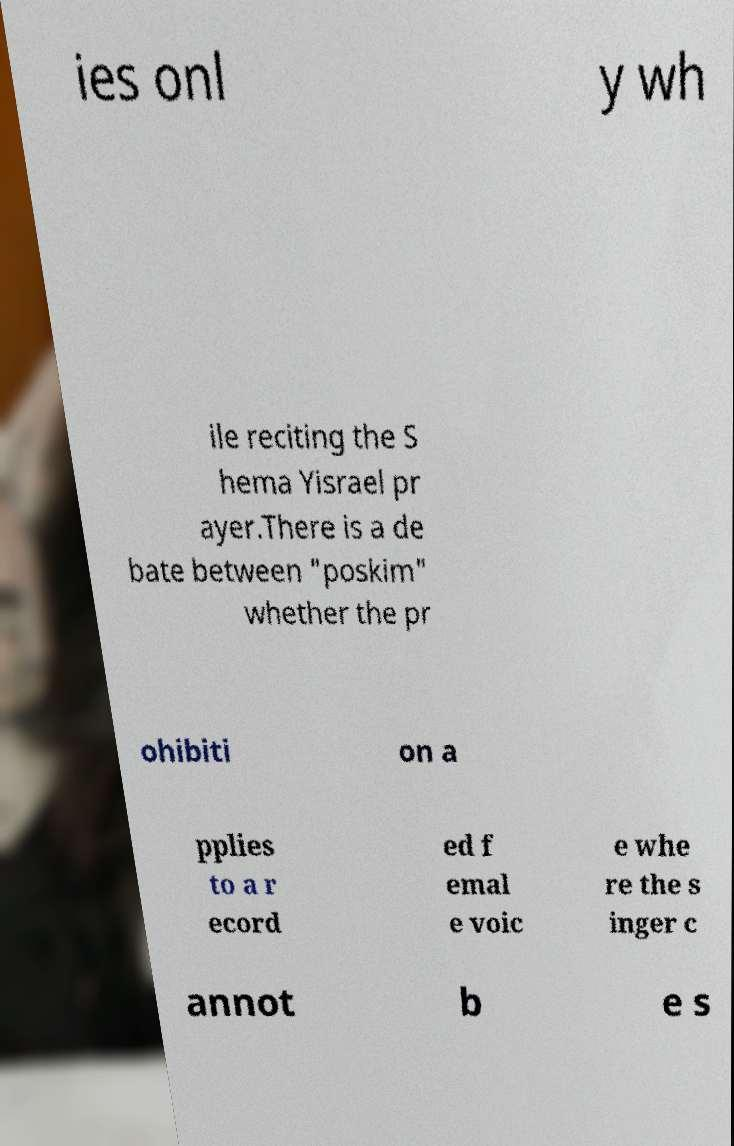I need the written content from this picture converted into text. Can you do that? ies onl y wh ile reciting the S hema Yisrael pr ayer.There is a de bate between "poskim" whether the pr ohibiti on a pplies to a r ecord ed f emal e voic e whe re the s inger c annot b e s 